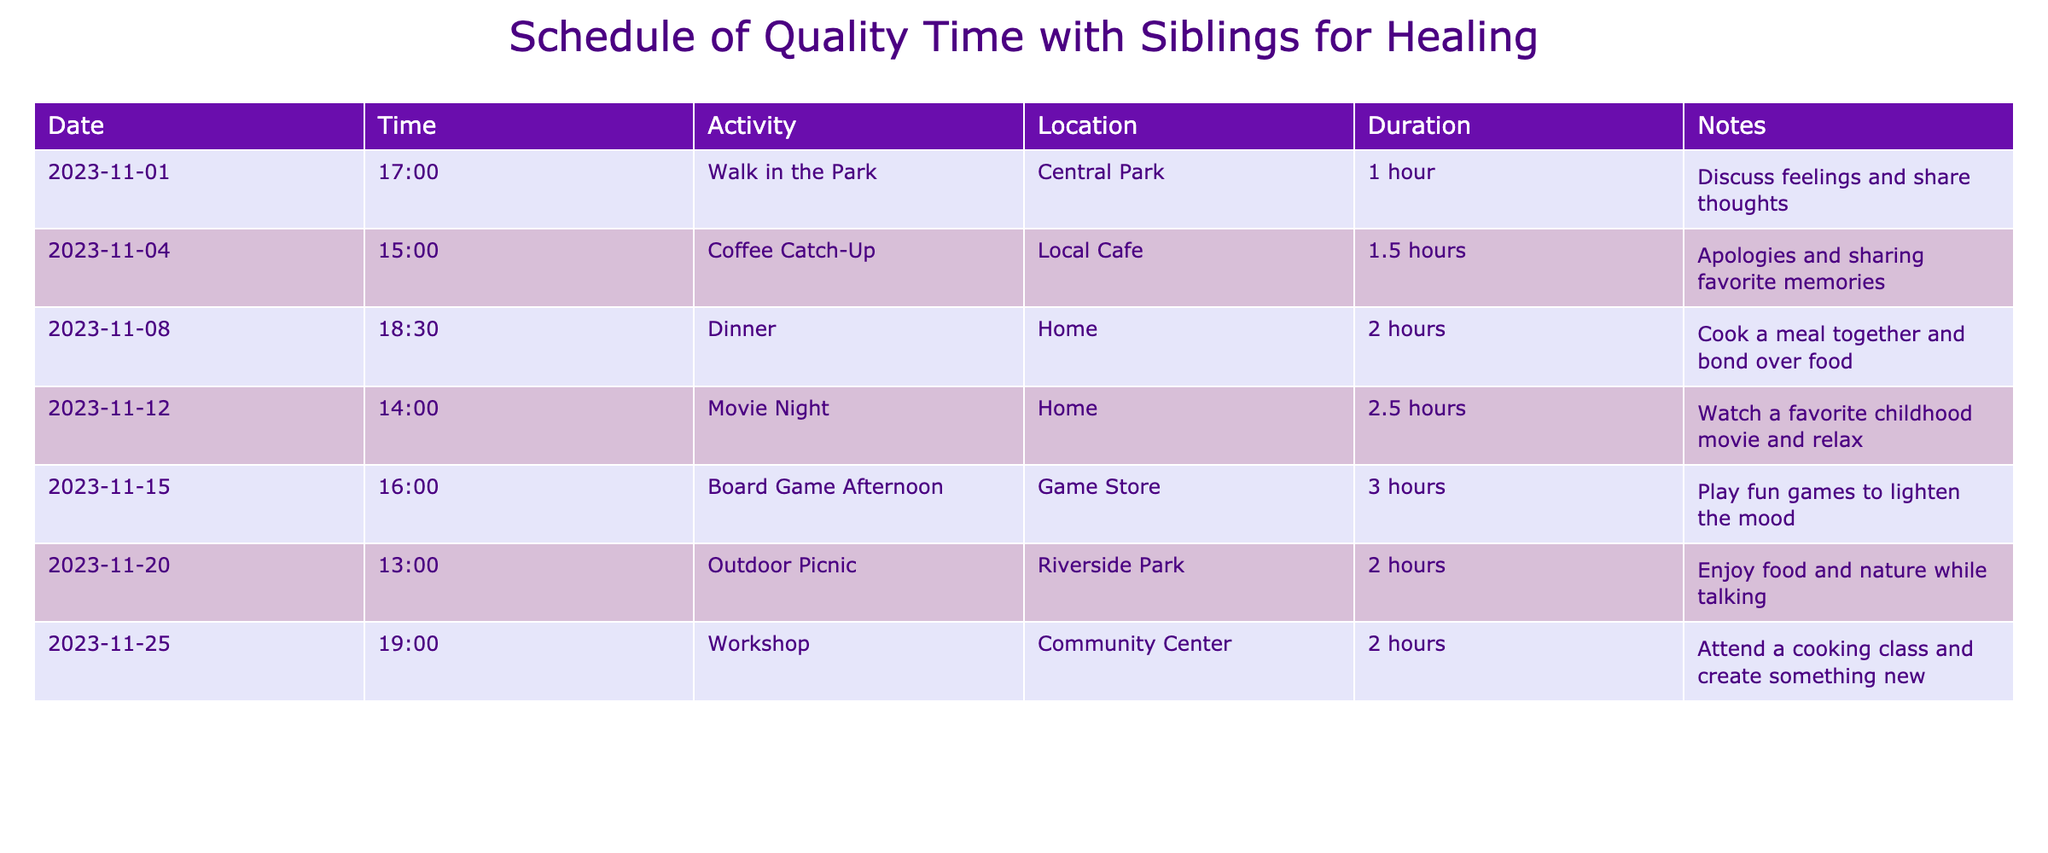What is the duration of the Dinner activity on November 8th? The duration for the Dinner activity listed under the date 2023-11-08 is stated directly in the table as 2 hours.
Answer: 2 hours What is the location for the Coffee Catch-Up on November 4th? The location for the Coffee Catch-Up activity noted in the table for the date 2023-11-04 is "Local Cafe."
Answer: Local Cafe How many hours is the total scheduled time for activities from November 1st to November 25th? By adding the durations of each activity: 1 + 1.5 + 2 + 2.5 + 3 + 2 + 2 = 14 hours total.
Answer: 14 hours Is there a discussion of feelings planned during any of the activities? Yes, the activity on November 1st, titled "Walk in the Park," includes a focus on discussing feelings and sharing thoughts, which confirms this as true.
Answer: Yes On which date is the Outdoor Picnic scheduled, and how long will it last? The Outdoor Picnic is scheduled for November 20th and has a duration of 2 hours, which is reflected in the table.
Answer: November 20th, 2 hours What activity takes place on the 15th of November, and how long is it? The activity on November 15th is the "Board Game Afternoon," which lasts for 3 hours according to the table.
Answer: Board Game Afternoon, 3 hours Which activity has the longest duration, and how long is it? The activity with the longest duration is the "Board Game Afternoon" with a total duration of 3 hours, based on the listed durations in the table.
Answer: Board Game Afternoon, 3 hours What is the main purpose of the activities listed in the schedule? The schedule is focused on quality time with siblings for the purpose of healing, as indicated by the activities and notes.
Answer: Quality time for healing 